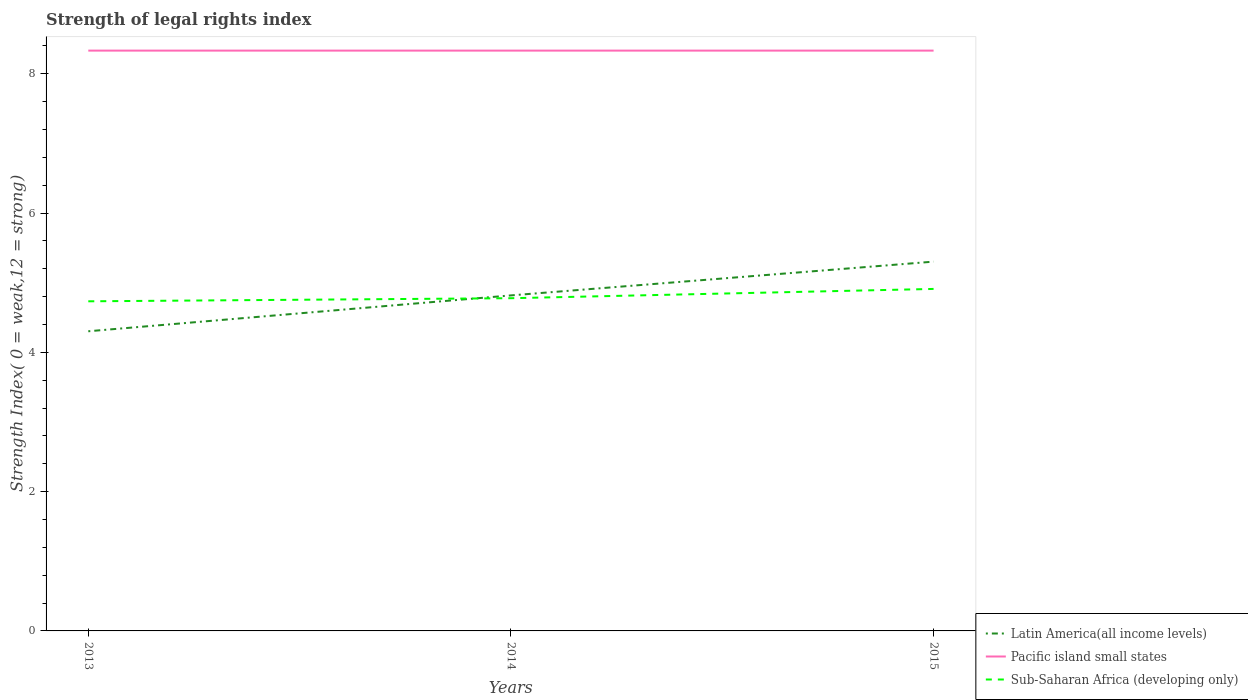Is the number of lines equal to the number of legend labels?
Your answer should be compact. Yes. Across all years, what is the maximum strength index in Latin America(all income levels)?
Your answer should be compact. 4.3. In which year was the strength index in Sub-Saharan Africa (developing only) maximum?
Give a very brief answer. 2013. What is the difference between the highest and the second highest strength index in Sub-Saharan Africa (developing only)?
Offer a terse response. 0.18. How many lines are there?
Your answer should be very brief. 3. How many years are there in the graph?
Offer a terse response. 3. What is the difference between two consecutive major ticks on the Y-axis?
Keep it short and to the point. 2. Are the values on the major ticks of Y-axis written in scientific E-notation?
Your answer should be very brief. No. Does the graph contain any zero values?
Your answer should be very brief. No. Does the graph contain grids?
Your answer should be very brief. No. What is the title of the graph?
Keep it short and to the point. Strength of legal rights index. What is the label or title of the Y-axis?
Provide a short and direct response. Strength Index( 0 = weak,12 = strong). What is the Strength Index( 0 = weak,12 = strong) of Latin America(all income levels) in 2013?
Your answer should be very brief. 4.3. What is the Strength Index( 0 = weak,12 = strong) in Pacific island small states in 2013?
Keep it short and to the point. 8.33. What is the Strength Index( 0 = weak,12 = strong) of Sub-Saharan Africa (developing only) in 2013?
Ensure brevity in your answer.  4.73. What is the Strength Index( 0 = weak,12 = strong) of Latin America(all income levels) in 2014?
Your answer should be very brief. 4.82. What is the Strength Index( 0 = weak,12 = strong) in Pacific island small states in 2014?
Keep it short and to the point. 8.33. What is the Strength Index( 0 = weak,12 = strong) in Sub-Saharan Africa (developing only) in 2014?
Offer a terse response. 4.78. What is the Strength Index( 0 = weak,12 = strong) in Latin America(all income levels) in 2015?
Give a very brief answer. 5.3. What is the Strength Index( 0 = weak,12 = strong) in Pacific island small states in 2015?
Offer a very short reply. 8.33. What is the Strength Index( 0 = weak,12 = strong) of Sub-Saharan Africa (developing only) in 2015?
Offer a terse response. 4.91. Across all years, what is the maximum Strength Index( 0 = weak,12 = strong) in Latin America(all income levels)?
Your answer should be compact. 5.3. Across all years, what is the maximum Strength Index( 0 = weak,12 = strong) in Pacific island small states?
Provide a short and direct response. 8.33. Across all years, what is the maximum Strength Index( 0 = weak,12 = strong) in Sub-Saharan Africa (developing only)?
Your response must be concise. 4.91. Across all years, what is the minimum Strength Index( 0 = weak,12 = strong) in Latin America(all income levels)?
Your answer should be compact. 4.3. Across all years, what is the minimum Strength Index( 0 = weak,12 = strong) in Pacific island small states?
Give a very brief answer. 8.33. Across all years, what is the minimum Strength Index( 0 = weak,12 = strong) in Sub-Saharan Africa (developing only)?
Offer a very short reply. 4.73. What is the total Strength Index( 0 = weak,12 = strong) of Latin America(all income levels) in the graph?
Make the answer very short. 14.42. What is the total Strength Index( 0 = weak,12 = strong) of Pacific island small states in the graph?
Keep it short and to the point. 25. What is the total Strength Index( 0 = weak,12 = strong) of Sub-Saharan Africa (developing only) in the graph?
Give a very brief answer. 14.42. What is the difference between the Strength Index( 0 = weak,12 = strong) of Latin America(all income levels) in 2013 and that in 2014?
Provide a succinct answer. -0.52. What is the difference between the Strength Index( 0 = weak,12 = strong) in Sub-Saharan Africa (developing only) in 2013 and that in 2014?
Provide a short and direct response. -0.04. What is the difference between the Strength Index( 0 = weak,12 = strong) in Sub-Saharan Africa (developing only) in 2013 and that in 2015?
Your response must be concise. -0.18. What is the difference between the Strength Index( 0 = weak,12 = strong) in Latin America(all income levels) in 2014 and that in 2015?
Your response must be concise. -0.48. What is the difference between the Strength Index( 0 = weak,12 = strong) of Pacific island small states in 2014 and that in 2015?
Make the answer very short. 0. What is the difference between the Strength Index( 0 = weak,12 = strong) of Sub-Saharan Africa (developing only) in 2014 and that in 2015?
Provide a short and direct response. -0.13. What is the difference between the Strength Index( 0 = weak,12 = strong) of Latin America(all income levels) in 2013 and the Strength Index( 0 = weak,12 = strong) of Pacific island small states in 2014?
Your response must be concise. -4.03. What is the difference between the Strength Index( 0 = weak,12 = strong) in Latin America(all income levels) in 2013 and the Strength Index( 0 = weak,12 = strong) in Sub-Saharan Africa (developing only) in 2014?
Your response must be concise. -0.47. What is the difference between the Strength Index( 0 = weak,12 = strong) in Pacific island small states in 2013 and the Strength Index( 0 = weak,12 = strong) in Sub-Saharan Africa (developing only) in 2014?
Make the answer very short. 3.56. What is the difference between the Strength Index( 0 = weak,12 = strong) of Latin America(all income levels) in 2013 and the Strength Index( 0 = weak,12 = strong) of Pacific island small states in 2015?
Your answer should be very brief. -4.03. What is the difference between the Strength Index( 0 = weak,12 = strong) in Latin America(all income levels) in 2013 and the Strength Index( 0 = weak,12 = strong) in Sub-Saharan Africa (developing only) in 2015?
Give a very brief answer. -0.61. What is the difference between the Strength Index( 0 = weak,12 = strong) of Pacific island small states in 2013 and the Strength Index( 0 = weak,12 = strong) of Sub-Saharan Africa (developing only) in 2015?
Your response must be concise. 3.42. What is the difference between the Strength Index( 0 = weak,12 = strong) in Latin America(all income levels) in 2014 and the Strength Index( 0 = weak,12 = strong) in Pacific island small states in 2015?
Your answer should be compact. -3.52. What is the difference between the Strength Index( 0 = weak,12 = strong) in Latin America(all income levels) in 2014 and the Strength Index( 0 = weak,12 = strong) in Sub-Saharan Africa (developing only) in 2015?
Your response must be concise. -0.09. What is the difference between the Strength Index( 0 = weak,12 = strong) in Pacific island small states in 2014 and the Strength Index( 0 = weak,12 = strong) in Sub-Saharan Africa (developing only) in 2015?
Your response must be concise. 3.42. What is the average Strength Index( 0 = weak,12 = strong) in Latin America(all income levels) per year?
Offer a terse response. 4.81. What is the average Strength Index( 0 = weak,12 = strong) of Pacific island small states per year?
Your answer should be compact. 8.33. What is the average Strength Index( 0 = weak,12 = strong) in Sub-Saharan Africa (developing only) per year?
Provide a short and direct response. 4.81. In the year 2013, what is the difference between the Strength Index( 0 = weak,12 = strong) of Latin America(all income levels) and Strength Index( 0 = weak,12 = strong) of Pacific island small states?
Give a very brief answer. -4.03. In the year 2013, what is the difference between the Strength Index( 0 = weak,12 = strong) in Latin America(all income levels) and Strength Index( 0 = weak,12 = strong) in Sub-Saharan Africa (developing only)?
Give a very brief answer. -0.43. In the year 2014, what is the difference between the Strength Index( 0 = weak,12 = strong) in Latin America(all income levels) and Strength Index( 0 = weak,12 = strong) in Pacific island small states?
Ensure brevity in your answer.  -3.52. In the year 2014, what is the difference between the Strength Index( 0 = weak,12 = strong) in Latin America(all income levels) and Strength Index( 0 = weak,12 = strong) in Sub-Saharan Africa (developing only)?
Your answer should be compact. 0.04. In the year 2014, what is the difference between the Strength Index( 0 = weak,12 = strong) of Pacific island small states and Strength Index( 0 = weak,12 = strong) of Sub-Saharan Africa (developing only)?
Give a very brief answer. 3.56. In the year 2015, what is the difference between the Strength Index( 0 = weak,12 = strong) in Latin America(all income levels) and Strength Index( 0 = weak,12 = strong) in Pacific island small states?
Your answer should be compact. -3.03. In the year 2015, what is the difference between the Strength Index( 0 = weak,12 = strong) in Latin America(all income levels) and Strength Index( 0 = weak,12 = strong) in Sub-Saharan Africa (developing only)?
Give a very brief answer. 0.39. In the year 2015, what is the difference between the Strength Index( 0 = weak,12 = strong) in Pacific island small states and Strength Index( 0 = weak,12 = strong) in Sub-Saharan Africa (developing only)?
Offer a very short reply. 3.42. What is the ratio of the Strength Index( 0 = weak,12 = strong) of Latin America(all income levels) in 2013 to that in 2014?
Make the answer very short. 0.89. What is the ratio of the Strength Index( 0 = weak,12 = strong) of Pacific island small states in 2013 to that in 2014?
Provide a short and direct response. 1. What is the ratio of the Strength Index( 0 = weak,12 = strong) in Latin America(all income levels) in 2013 to that in 2015?
Provide a short and direct response. 0.81. What is the ratio of the Strength Index( 0 = weak,12 = strong) in Sub-Saharan Africa (developing only) in 2013 to that in 2015?
Provide a succinct answer. 0.96. What is the ratio of the Strength Index( 0 = weak,12 = strong) of Latin America(all income levels) in 2014 to that in 2015?
Provide a short and direct response. 0.91. What is the ratio of the Strength Index( 0 = weak,12 = strong) in Pacific island small states in 2014 to that in 2015?
Provide a short and direct response. 1. What is the ratio of the Strength Index( 0 = weak,12 = strong) in Sub-Saharan Africa (developing only) in 2014 to that in 2015?
Provide a succinct answer. 0.97. What is the difference between the highest and the second highest Strength Index( 0 = weak,12 = strong) in Latin America(all income levels)?
Give a very brief answer. 0.48. What is the difference between the highest and the second highest Strength Index( 0 = weak,12 = strong) in Pacific island small states?
Provide a succinct answer. 0. What is the difference between the highest and the second highest Strength Index( 0 = weak,12 = strong) in Sub-Saharan Africa (developing only)?
Ensure brevity in your answer.  0.13. What is the difference between the highest and the lowest Strength Index( 0 = weak,12 = strong) of Latin America(all income levels)?
Make the answer very short. 1. What is the difference between the highest and the lowest Strength Index( 0 = weak,12 = strong) of Sub-Saharan Africa (developing only)?
Keep it short and to the point. 0.18. 